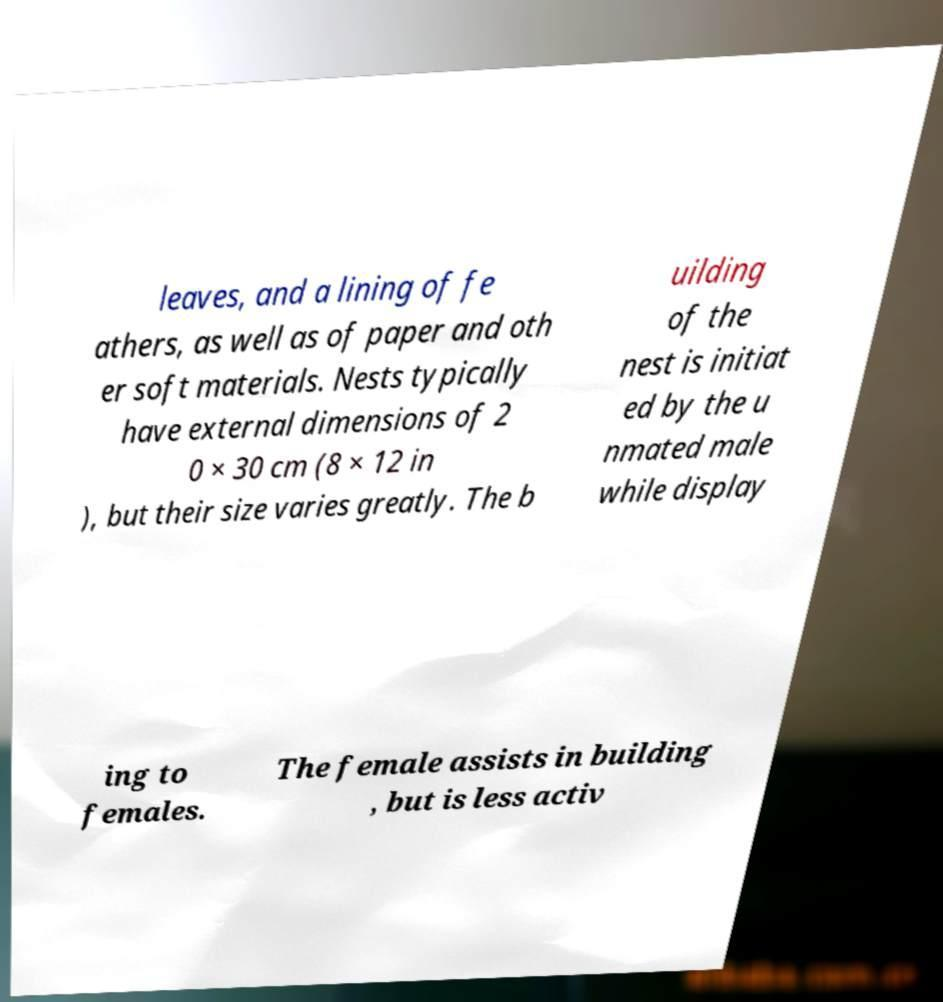Please read and relay the text visible in this image. What does it say? leaves, and a lining of fe athers, as well as of paper and oth er soft materials. Nests typically have external dimensions of 2 0 × 30 cm (8 × 12 in ), but their size varies greatly. The b uilding of the nest is initiat ed by the u nmated male while display ing to females. The female assists in building , but is less activ 